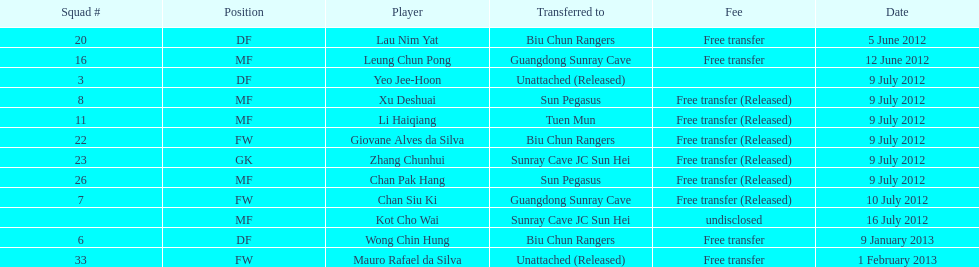Player transferred immediately before mauro rafael da silva Wong Chin Hung. 